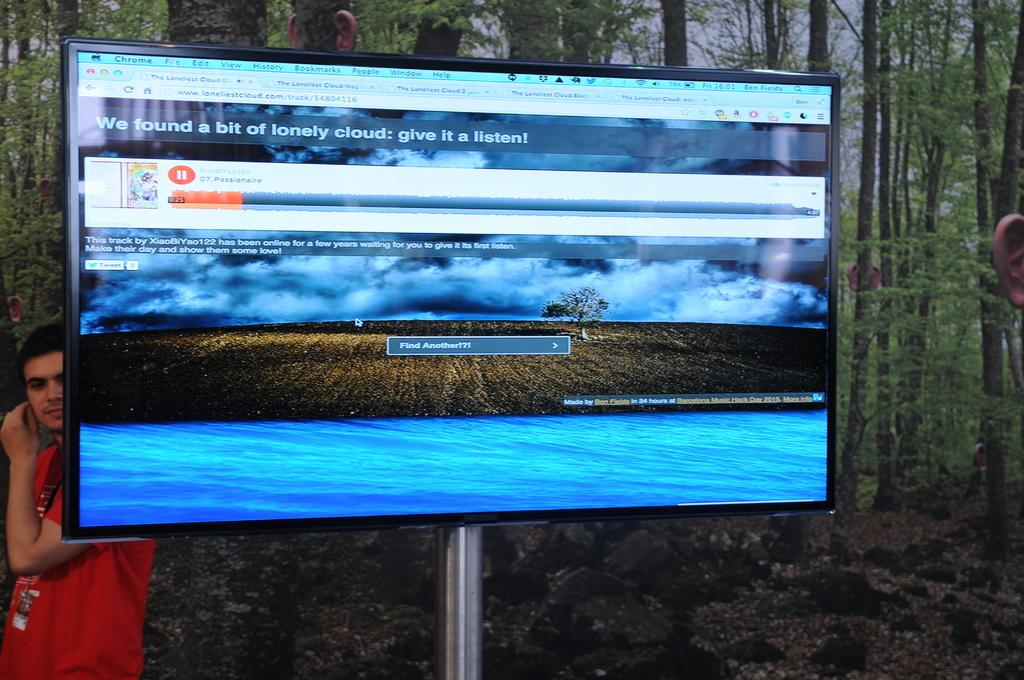<image>
Give a short and clear explanation of the subsequent image. A TV on a stand shows a picture of a field and the sky upon which is written we found a bit of a lonely cloud. 